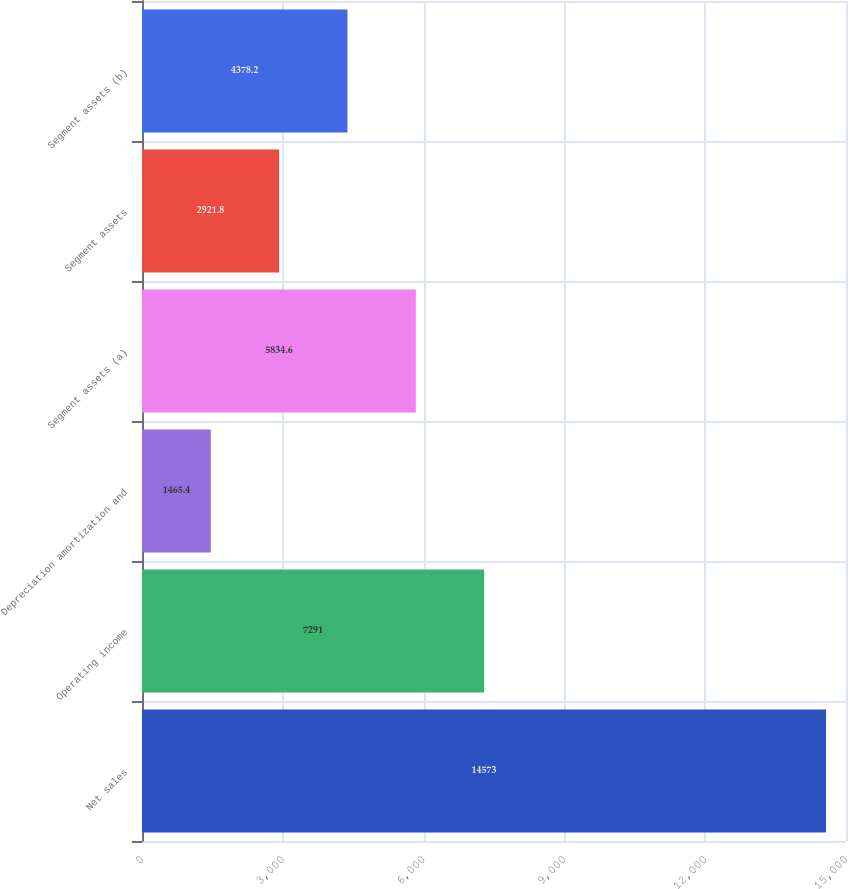<chart> <loc_0><loc_0><loc_500><loc_500><bar_chart><fcel>Net sales<fcel>Operating income<fcel>Depreciation amortization and<fcel>Segment assets (a)<fcel>Segment assets<fcel>Segment assets (b)<nl><fcel>14573<fcel>7291<fcel>1465.4<fcel>5834.6<fcel>2921.8<fcel>4378.2<nl></chart> 